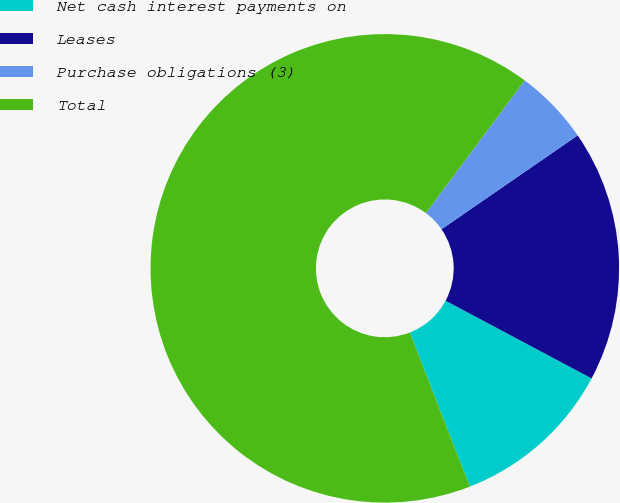Convert chart to OTSL. <chart><loc_0><loc_0><loc_500><loc_500><pie_chart><fcel>Net cash interest payments on<fcel>Leases<fcel>Purchase obligations (3)<fcel>Total<nl><fcel>11.3%<fcel>17.39%<fcel>5.21%<fcel>66.1%<nl></chart> 